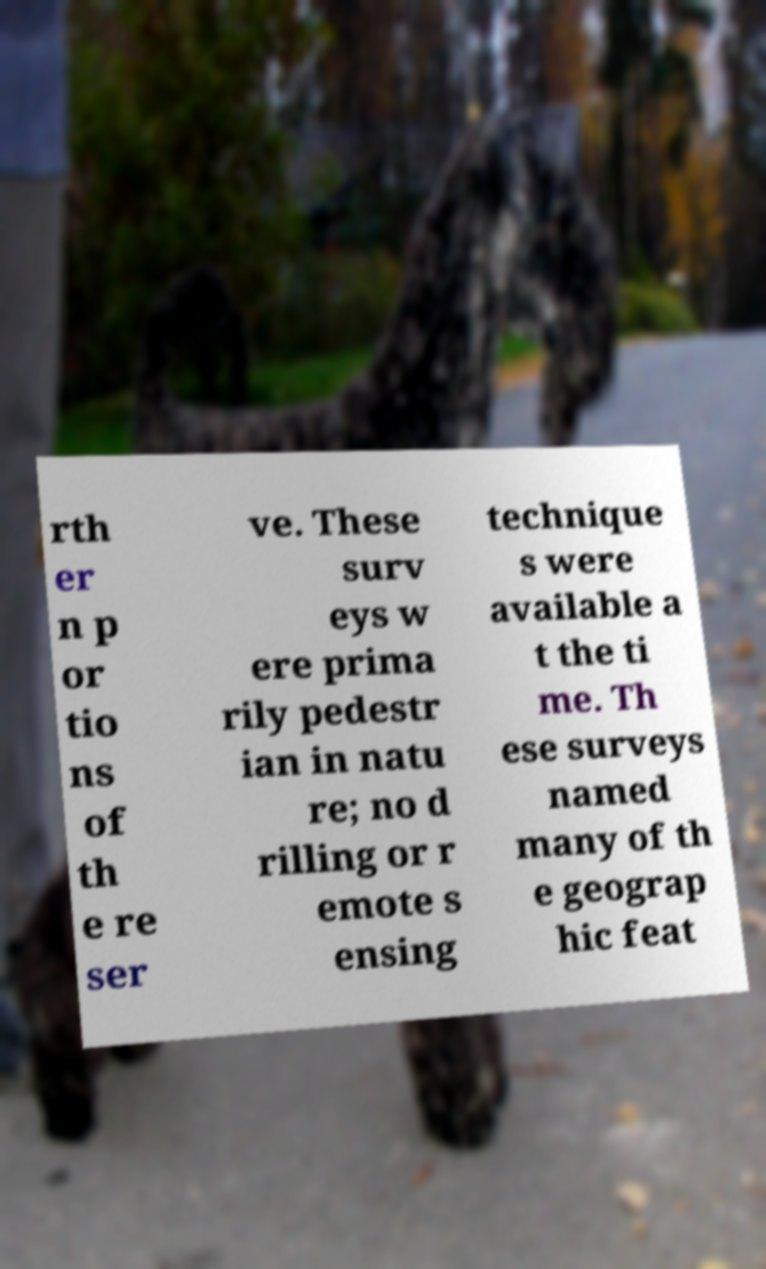Please read and relay the text visible in this image. What does it say? rth er n p or tio ns of th e re ser ve. These surv eys w ere prima rily pedestr ian in natu re; no d rilling or r emote s ensing technique s were available a t the ti me. Th ese surveys named many of th e geograp hic feat 